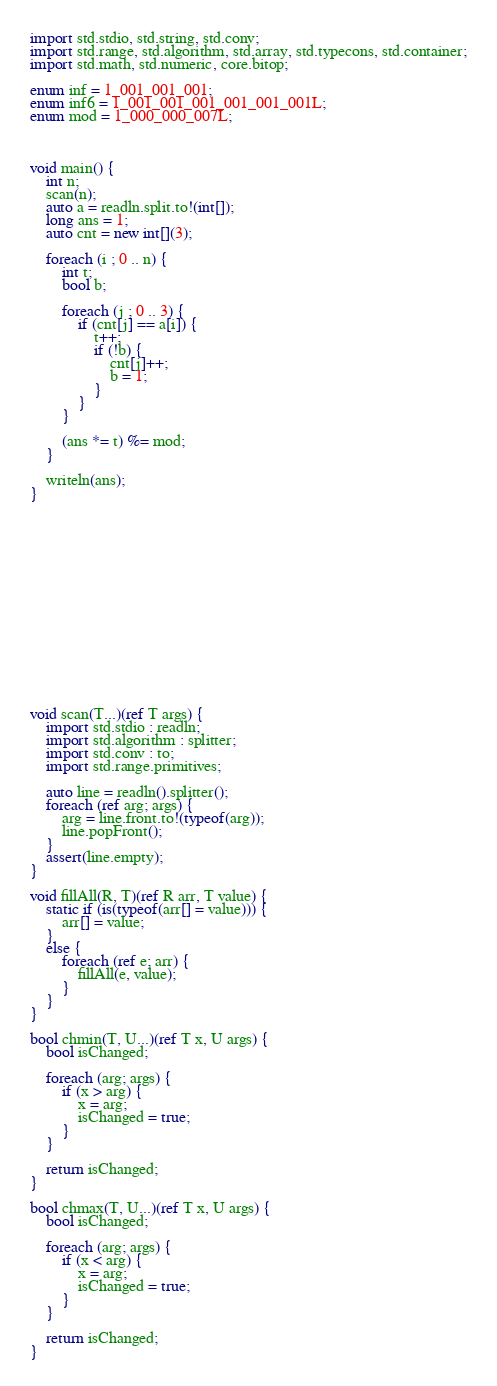Convert code to text. <code><loc_0><loc_0><loc_500><loc_500><_D_>import std.stdio, std.string, std.conv;
import std.range, std.algorithm, std.array, std.typecons, std.container;
import std.math, std.numeric, core.bitop;

enum inf = 1_001_001_001;
enum inf6 = 1_001_001_001_001_001_001L;
enum mod = 1_000_000_007L;



void main() {
    int n;
    scan(n);
    auto a = readln.split.to!(int[]);
    long ans = 1;
    auto cnt = new int[](3);

    foreach (i ; 0 .. n) {
        int t;
        bool b;

        foreach (j ; 0 .. 3) {
            if (cnt[j] == a[i]) {
                t++;
                if (!b) {
                    cnt[j]++;
                    b = 1;
                }
            }
        }

        (ans *= t) %= mod;
    }

    writeln(ans);
}
















void scan(T...)(ref T args) {
    import std.stdio : readln;
    import std.algorithm : splitter;
    import std.conv : to;
    import std.range.primitives;

    auto line = readln().splitter();
    foreach (ref arg; args) {
        arg = line.front.to!(typeof(arg));
        line.popFront();
    }
    assert(line.empty);
}

void fillAll(R, T)(ref R arr, T value) {
    static if (is(typeof(arr[] = value))) {
        arr[] = value;
    }
    else {
        foreach (ref e; arr) {
            fillAll(e, value);
        }
    }
}

bool chmin(T, U...)(ref T x, U args) {
    bool isChanged;

    foreach (arg; args) {
        if (x > arg) {
            x = arg;
            isChanged = true;
        }
    }

    return isChanged;
}

bool chmax(T, U...)(ref T x, U args) {
    bool isChanged;

    foreach (arg; args) {
        if (x < arg) {
            x = arg;
            isChanged = true;
        }
    }

    return isChanged;
}
</code> 